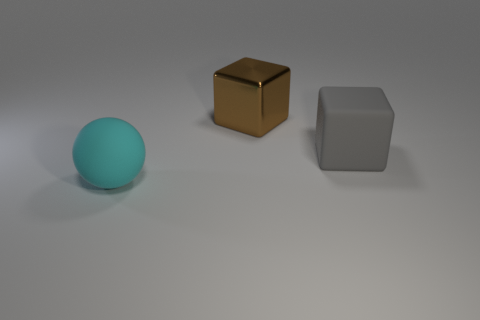Add 3 green shiny spheres. How many objects exist? 6 Subtract all cubes. How many objects are left? 1 Subtract all brown metallic blocks. Subtract all brown shiny cubes. How many objects are left? 1 Add 1 metal things. How many metal things are left? 2 Add 2 small purple matte cylinders. How many small purple matte cylinders exist? 2 Subtract 1 cyan balls. How many objects are left? 2 